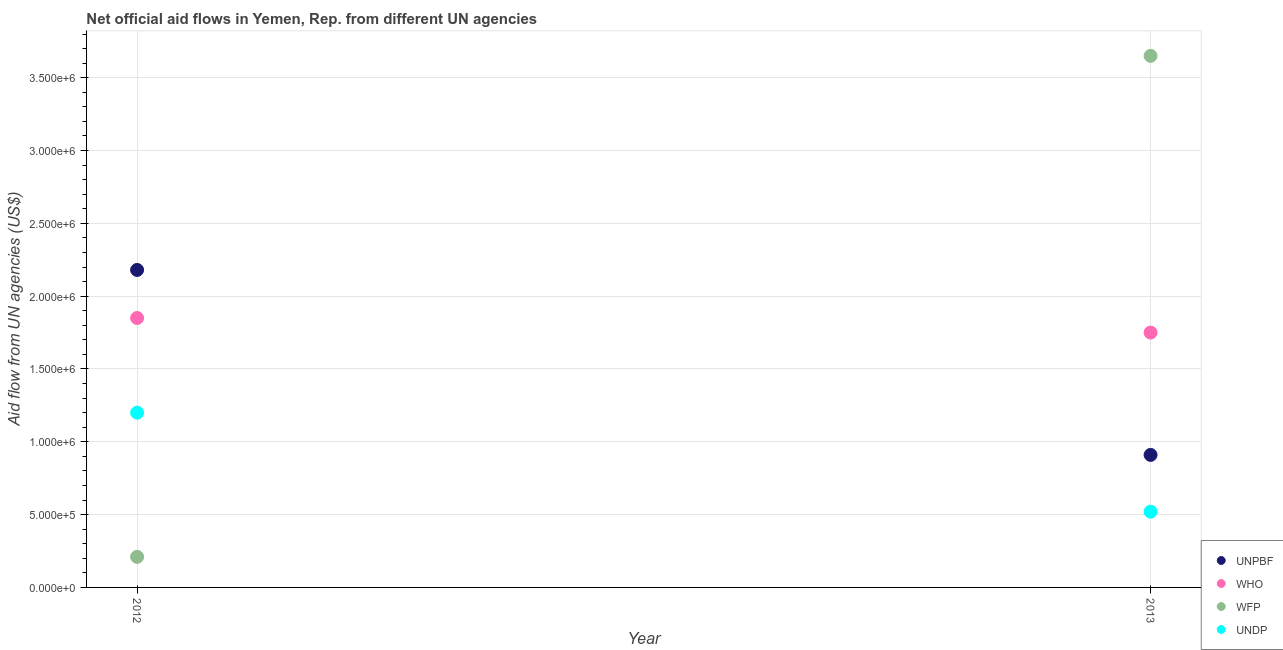How many different coloured dotlines are there?
Make the answer very short. 4. Is the number of dotlines equal to the number of legend labels?
Offer a terse response. Yes. What is the amount of aid given by who in 2012?
Ensure brevity in your answer.  1.85e+06. Across all years, what is the maximum amount of aid given by unpbf?
Provide a short and direct response. 2.18e+06. Across all years, what is the minimum amount of aid given by wfp?
Ensure brevity in your answer.  2.10e+05. What is the total amount of aid given by wfp in the graph?
Offer a terse response. 3.86e+06. What is the difference between the amount of aid given by unpbf in 2012 and that in 2013?
Your answer should be compact. 1.27e+06. What is the difference between the amount of aid given by who in 2012 and the amount of aid given by undp in 2013?
Offer a very short reply. 1.33e+06. What is the average amount of aid given by who per year?
Offer a terse response. 1.80e+06. In the year 2013, what is the difference between the amount of aid given by undp and amount of aid given by unpbf?
Ensure brevity in your answer.  -3.90e+05. What is the ratio of the amount of aid given by who in 2012 to that in 2013?
Make the answer very short. 1.06. Is the amount of aid given by unpbf strictly less than the amount of aid given by who over the years?
Offer a very short reply. No. What is the difference between two consecutive major ticks on the Y-axis?
Give a very brief answer. 5.00e+05. Are the values on the major ticks of Y-axis written in scientific E-notation?
Give a very brief answer. Yes. Does the graph contain any zero values?
Keep it short and to the point. No. Does the graph contain grids?
Your answer should be compact. Yes. Where does the legend appear in the graph?
Keep it short and to the point. Bottom right. How many legend labels are there?
Offer a very short reply. 4. How are the legend labels stacked?
Your response must be concise. Vertical. What is the title of the graph?
Ensure brevity in your answer.  Net official aid flows in Yemen, Rep. from different UN agencies. Does "Subsidies and Transfers" appear as one of the legend labels in the graph?
Ensure brevity in your answer.  No. What is the label or title of the X-axis?
Your answer should be very brief. Year. What is the label or title of the Y-axis?
Give a very brief answer. Aid flow from UN agencies (US$). What is the Aid flow from UN agencies (US$) in UNPBF in 2012?
Offer a very short reply. 2.18e+06. What is the Aid flow from UN agencies (US$) in WHO in 2012?
Offer a terse response. 1.85e+06. What is the Aid flow from UN agencies (US$) of UNDP in 2012?
Your response must be concise. 1.20e+06. What is the Aid flow from UN agencies (US$) in UNPBF in 2013?
Your answer should be very brief. 9.10e+05. What is the Aid flow from UN agencies (US$) of WHO in 2013?
Provide a short and direct response. 1.75e+06. What is the Aid flow from UN agencies (US$) in WFP in 2013?
Keep it short and to the point. 3.65e+06. What is the Aid flow from UN agencies (US$) in UNDP in 2013?
Ensure brevity in your answer.  5.20e+05. Across all years, what is the maximum Aid flow from UN agencies (US$) in UNPBF?
Offer a very short reply. 2.18e+06. Across all years, what is the maximum Aid flow from UN agencies (US$) in WHO?
Your answer should be compact. 1.85e+06. Across all years, what is the maximum Aid flow from UN agencies (US$) in WFP?
Your response must be concise. 3.65e+06. Across all years, what is the maximum Aid flow from UN agencies (US$) in UNDP?
Your response must be concise. 1.20e+06. Across all years, what is the minimum Aid flow from UN agencies (US$) in UNPBF?
Offer a terse response. 9.10e+05. Across all years, what is the minimum Aid flow from UN agencies (US$) of WHO?
Ensure brevity in your answer.  1.75e+06. Across all years, what is the minimum Aid flow from UN agencies (US$) in WFP?
Your response must be concise. 2.10e+05. Across all years, what is the minimum Aid flow from UN agencies (US$) of UNDP?
Ensure brevity in your answer.  5.20e+05. What is the total Aid flow from UN agencies (US$) of UNPBF in the graph?
Keep it short and to the point. 3.09e+06. What is the total Aid flow from UN agencies (US$) in WHO in the graph?
Your answer should be compact. 3.60e+06. What is the total Aid flow from UN agencies (US$) in WFP in the graph?
Offer a terse response. 3.86e+06. What is the total Aid flow from UN agencies (US$) in UNDP in the graph?
Your answer should be very brief. 1.72e+06. What is the difference between the Aid flow from UN agencies (US$) of UNPBF in 2012 and that in 2013?
Offer a very short reply. 1.27e+06. What is the difference between the Aid flow from UN agencies (US$) in WFP in 2012 and that in 2013?
Keep it short and to the point. -3.44e+06. What is the difference between the Aid flow from UN agencies (US$) in UNDP in 2012 and that in 2013?
Make the answer very short. 6.80e+05. What is the difference between the Aid flow from UN agencies (US$) of UNPBF in 2012 and the Aid flow from UN agencies (US$) of WHO in 2013?
Provide a succinct answer. 4.30e+05. What is the difference between the Aid flow from UN agencies (US$) of UNPBF in 2012 and the Aid flow from UN agencies (US$) of WFP in 2013?
Keep it short and to the point. -1.47e+06. What is the difference between the Aid flow from UN agencies (US$) of UNPBF in 2012 and the Aid flow from UN agencies (US$) of UNDP in 2013?
Your answer should be compact. 1.66e+06. What is the difference between the Aid flow from UN agencies (US$) of WHO in 2012 and the Aid flow from UN agencies (US$) of WFP in 2013?
Provide a short and direct response. -1.80e+06. What is the difference between the Aid flow from UN agencies (US$) of WHO in 2012 and the Aid flow from UN agencies (US$) of UNDP in 2013?
Your response must be concise. 1.33e+06. What is the difference between the Aid flow from UN agencies (US$) of WFP in 2012 and the Aid flow from UN agencies (US$) of UNDP in 2013?
Ensure brevity in your answer.  -3.10e+05. What is the average Aid flow from UN agencies (US$) in UNPBF per year?
Give a very brief answer. 1.54e+06. What is the average Aid flow from UN agencies (US$) of WHO per year?
Provide a short and direct response. 1.80e+06. What is the average Aid flow from UN agencies (US$) of WFP per year?
Your response must be concise. 1.93e+06. What is the average Aid flow from UN agencies (US$) of UNDP per year?
Your answer should be compact. 8.60e+05. In the year 2012, what is the difference between the Aid flow from UN agencies (US$) in UNPBF and Aid flow from UN agencies (US$) in WFP?
Your answer should be compact. 1.97e+06. In the year 2012, what is the difference between the Aid flow from UN agencies (US$) in UNPBF and Aid flow from UN agencies (US$) in UNDP?
Offer a terse response. 9.80e+05. In the year 2012, what is the difference between the Aid flow from UN agencies (US$) in WHO and Aid flow from UN agencies (US$) in WFP?
Provide a succinct answer. 1.64e+06. In the year 2012, what is the difference between the Aid flow from UN agencies (US$) in WHO and Aid flow from UN agencies (US$) in UNDP?
Provide a short and direct response. 6.50e+05. In the year 2012, what is the difference between the Aid flow from UN agencies (US$) in WFP and Aid flow from UN agencies (US$) in UNDP?
Provide a short and direct response. -9.90e+05. In the year 2013, what is the difference between the Aid flow from UN agencies (US$) in UNPBF and Aid flow from UN agencies (US$) in WHO?
Ensure brevity in your answer.  -8.40e+05. In the year 2013, what is the difference between the Aid flow from UN agencies (US$) of UNPBF and Aid flow from UN agencies (US$) of WFP?
Offer a very short reply. -2.74e+06. In the year 2013, what is the difference between the Aid flow from UN agencies (US$) of WHO and Aid flow from UN agencies (US$) of WFP?
Provide a succinct answer. -1.90e+06. In the year 2013, what is the difference between the Aid flow from UN agencies (US$) of WHO and Aid flow from UN agencies (US$) of UNDP?
Provide a succinct answer. 1.23e+06. In the year 2013, what is the difference between the Aid flow from UN agencies (US$) of WFP and Aid flow from UN agencies (US$) of UNDP?
Your answer should be compact. 3.13e+06. What is the ratio of the Aid flow from UN agencies (US$) of UNPBF in 2012 to that in 2013?
Provide a short and direct response. 2.4. What is the ratio of the Aid flow from UN agencies (US$) in WHO in 2012 to that in 2013?
Give a very brief answer. 1.06. What is the ratio of the Aid flow from UN agencies (US$) of WFP in 2012 to that in 2013?
Your response must be concise. 0.06. What is the ratio of the Aid flow from UN agencies (US$) in UNDP in 2012 to that in 2013?
Give a very brief answer. 2.31. What is the difference between the highest and the second highest Aid flow from UN agencies (US$) in UNPBF?
Provide a short and direct response. 1.27e+06. What is the difference between the highest and the second highest Aid flow from UN agencies (US$) of WHO?
Provide a short and direct response. 1.00e+05. What is the difference between the highest and the second highest Aid flow from UN agencies (US$) in WFP?
Ensure brevity in your answer.  3.44e+06. What is the difference between the highest and the second highest Aid flow from UN agencies (US$) in UNDP?
Keep it short and to the point. 6.80e+05. What is the difference between the highest and the lowest Aid flow from UN agencies (US$) of UNPBF?
Provide a succinct answer. 1.27e+06. What is the difference between the highest and the lowest Aid flow from UN agencies (US$) in WFP?
Make the answer very short. 3.44e+06. What is the difference between the highest and the lowest Aid flow from UN agencies (US$) of UNDP?
Your answer should be very brief. 6.80e+05. 